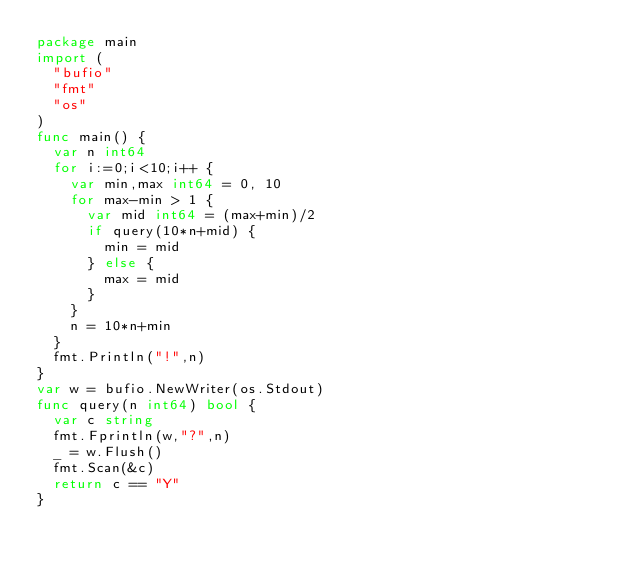<code> <loc_0><loc_0><loc_500><loc_500><_Go_>package main
import (
  "bufio"
  "fmt"
  "os"
)
func main() {
  var n int64
  for i:=0;i<10;i++ {
    var min,max int64 = 0, 10
    for max-min > 1 {
      var mid int64 = (max+min)/2
      if query(10*n+mid) {
        min = mid
      } else {
        max = mid
      }
    }
    n = 10*n+min
  }
  fmt.Println("!",n)
}
var w = bufio.NewWriter(os.Stdout)
func query(n int64) bool {
  var c string
  fmt.Fprintln(w,"?",n)
  _ = w.Flush()
  fmt.Scan(&c)
  return c == "Y"
}</code> 